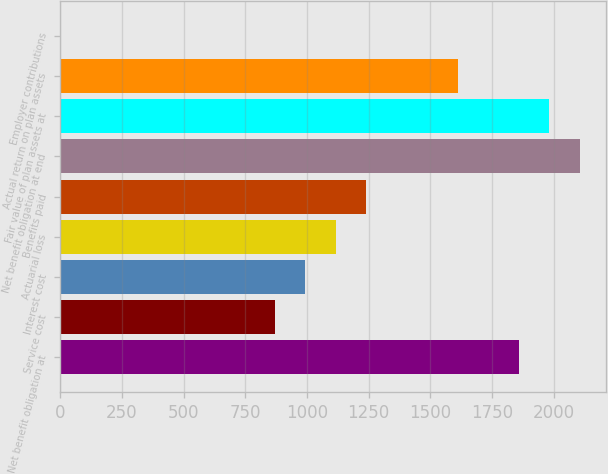Convert chart to OTSL. <chart><loc_0><loc_0><loc_500><loc_500><bar_chart><fcel>Net benefit obligation at<fcel>Service cost<fcel>Interest cost<fcel>Actuarial loss<fcel>Benefits paid<fcel>Net benefit obligation at end<fcel>Fair value of plan assets at<fcel>Actual return on plan assets<fcel>Employer contributions<nl><fcel>1859<fcel>868.6<fcel>992.4<fcel>1116.2<fcel>1240<fcel>2106.6<fcel>1982.8<fcel>1611.4<fcel>2<nl></chart> 